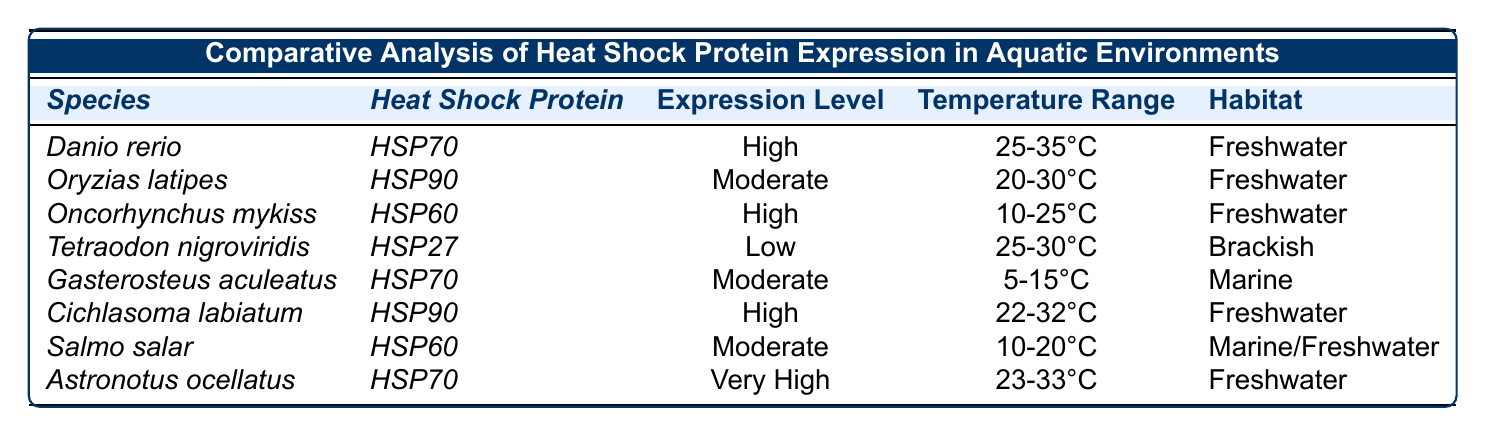What species exhibits the highest expression level of heat shock protein? The table shows that *Astronotus ocellatus* has an expression level of "Very High," which is the highest compared to the other species listed.
Answer: *Astronotus ocellatus* How many freshwater species express high levels of heat shock proteins? The table indicates that *Danio rerio*, *Oncorhynchus mykiss*, and *Cichlasoma labiatum* are freshwater species with "High" levels of heat shock protein expression, totaling three species.
Answer: 3 Is *Gasterosteus aculeatus* associated with a high expression level of any heat shock protein? According to the table, *Gasterosteus aculeatus* shows a "Moderate" expression level for *HSP70*, which is not high.
Answer: No Which heat shock protein is associated with the widest temperature range? The temperature ranges for the species are: *HSP70* (25-35°C), *HSP90* (20-30°C), *HSP60* (10-25°C), *HSP27* (25-30°C). The widest range is *HSP70* with 10°C difference.
Answer: *HSP70* What is the average expression level of heat shock proteins in marine habitats? In the table, *Gasterosteus aculeatus* has a "Moderate" level and *Salmo salar* has a "Moderate" level for heat shock proteins, resulting in an average of Moderate for both marine species.
Answer: Moderate How many species have a heat shock protein expressed at a low level? The table indicates that *Tetraodon nigroviridis* is the only species with an expression level marked as "Low." Thus, there is one species identified.
Answer: 1 Are any species expressing *HSP60* found in freshwater habitats? By examining the table, it shows that *Oncorhynchus mykiss* and *Salmo salar* express *HSP60*, but only *Oncorhynchus mykiss* is listed purely under "Freshwater."
Answer: Yes What is the temperature range for *HSP90* expressed by *Oryzias latipes*? The temperature range listed for *HSP90* and *Oryzias latipes* in the table is 20-30°C.
Answer: 20-30°C Which habitat has the highest expression levels of heat shock proteins? Among the species noted, freshwater habitats (*Danio rerio*, *Oncorhynchus mykiss*, *Cichlasoma labiatum*, *Astronotus ocellatus*) have high and very high expression levels, exceeding others categorized with moderate or low expressions.
Answer: Freshwater Identify the species with the lowest expression level and its habitat. The table clearly states that *Tetraodon nigroviridis* has the lowest expression level at "Low," and it is found in a "Brackish" habitat.
Answer: *Tetraodon nigroviridis*, Brackish 